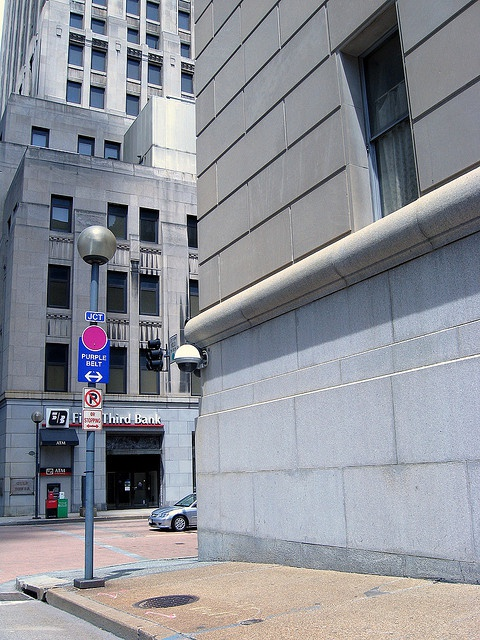Describe the objects in this image and their specific colors. I can see car in lightyellow, black, gray, darkgray, and white tones and traffic light in lightyellow, black, navy, and gray tones in this image. 